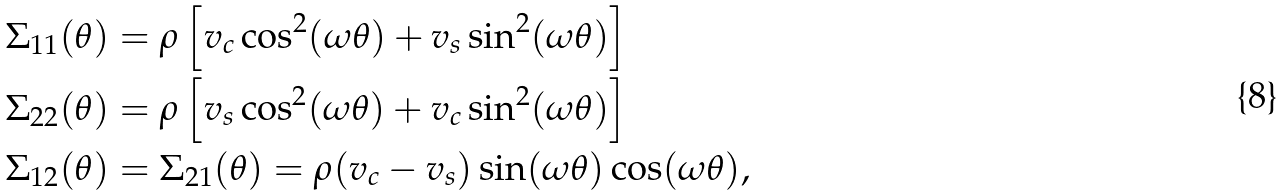<formula> <loc_0><loc_0><loc_500><loc_500>\Sigma _ { 1 1 } ( \theta ) & = \rho \left [ v _ { c } \cos ^ { 2 } ( \omega \theta ) + v _ { s } \sin ^ { 2 } ( \omega \theta ) \right ] \\ \Sigma _ { 2 2 } ( \theta ) & = \rho \left [ v _ { s } \cos ^ { 2 } ( \omega \theta ) + v _ { c } \sin ^ { 2 } ( \omega \theta ) \right ] \\ \Sigma _ { 1 2 } ( \theta ) & = \Sigma _ { 2 1 } ( \theta ) = \rho ( v _ { c } - v _ { s } ) \sin ( \omega \theta ) \cos ( \omega \theta ) ,</formula> 